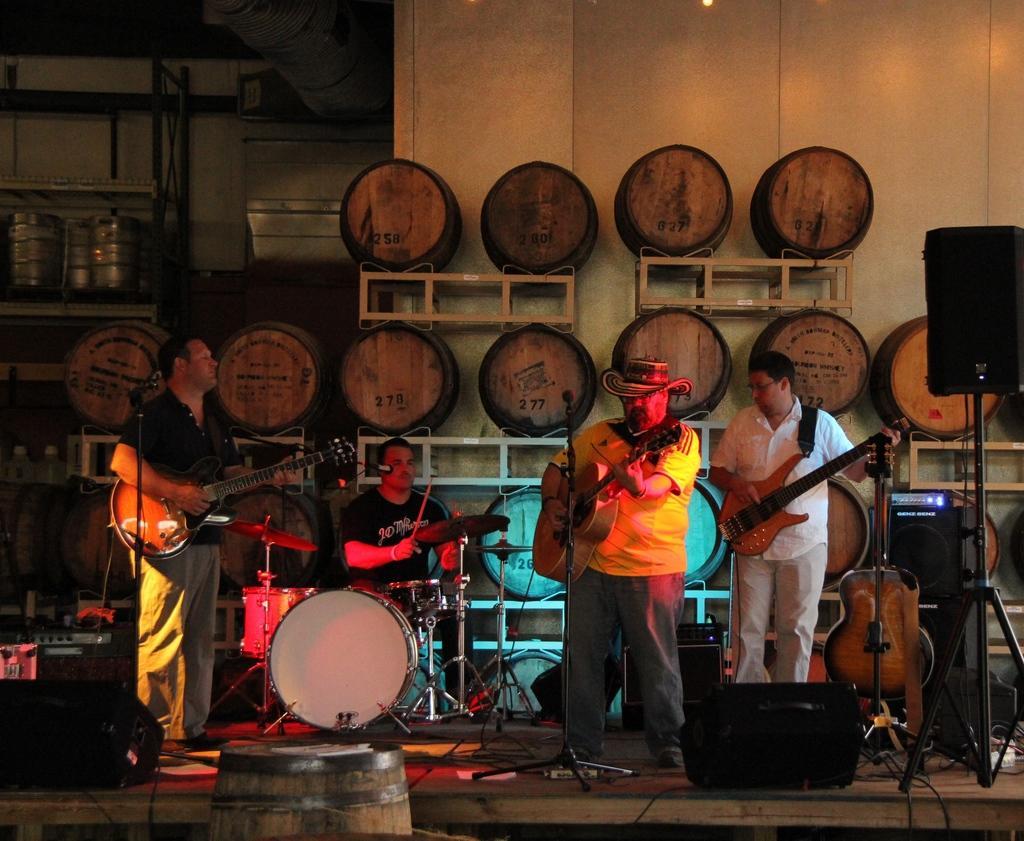Could you give a brief overview of what you see in this image? The picture is taken inside a room. There are four men playing music instruments on the dais. The man to the left is playing guitar and beside him other man is playing drums. The other to men at the right are also standing and playing guitars. One among them is wearing hat. On the dais there is another guitar, microphone, microphone stand, drum stand and cables. There is also speaker placed on tripod stand. In the background there is a wall and racks and barrels are placed in it.  